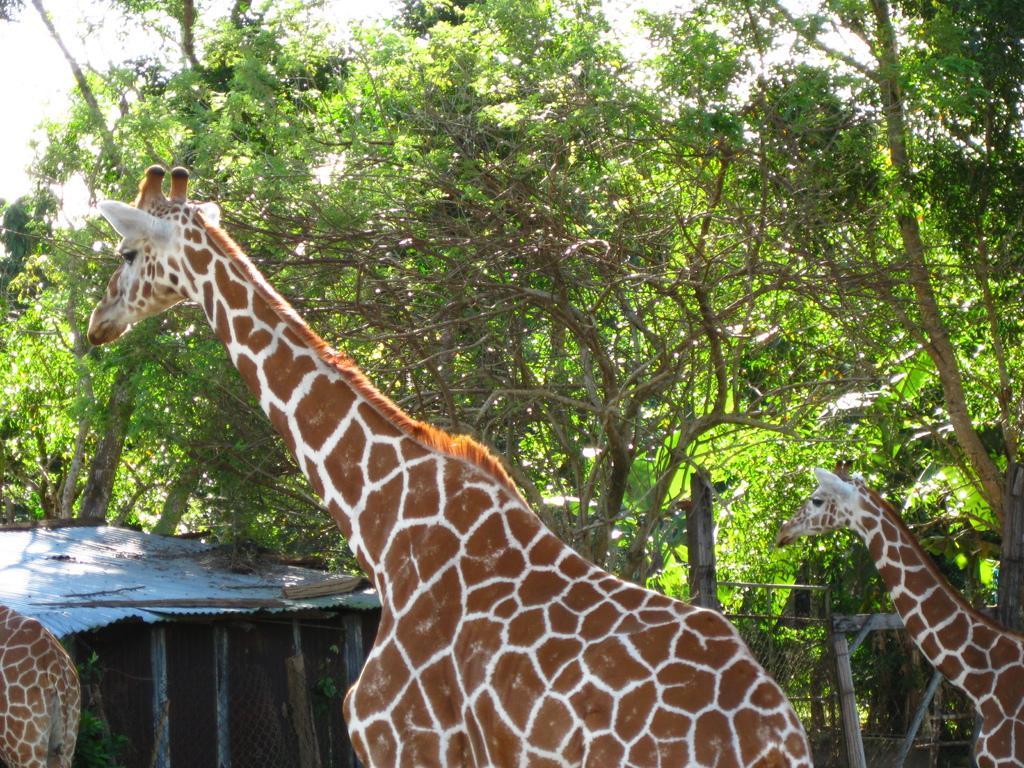In one or two sentences, can you explain what this image depicts? In this image we can see few giraffes and there is a shed and we can see some trees in the background and we can see the sky. 